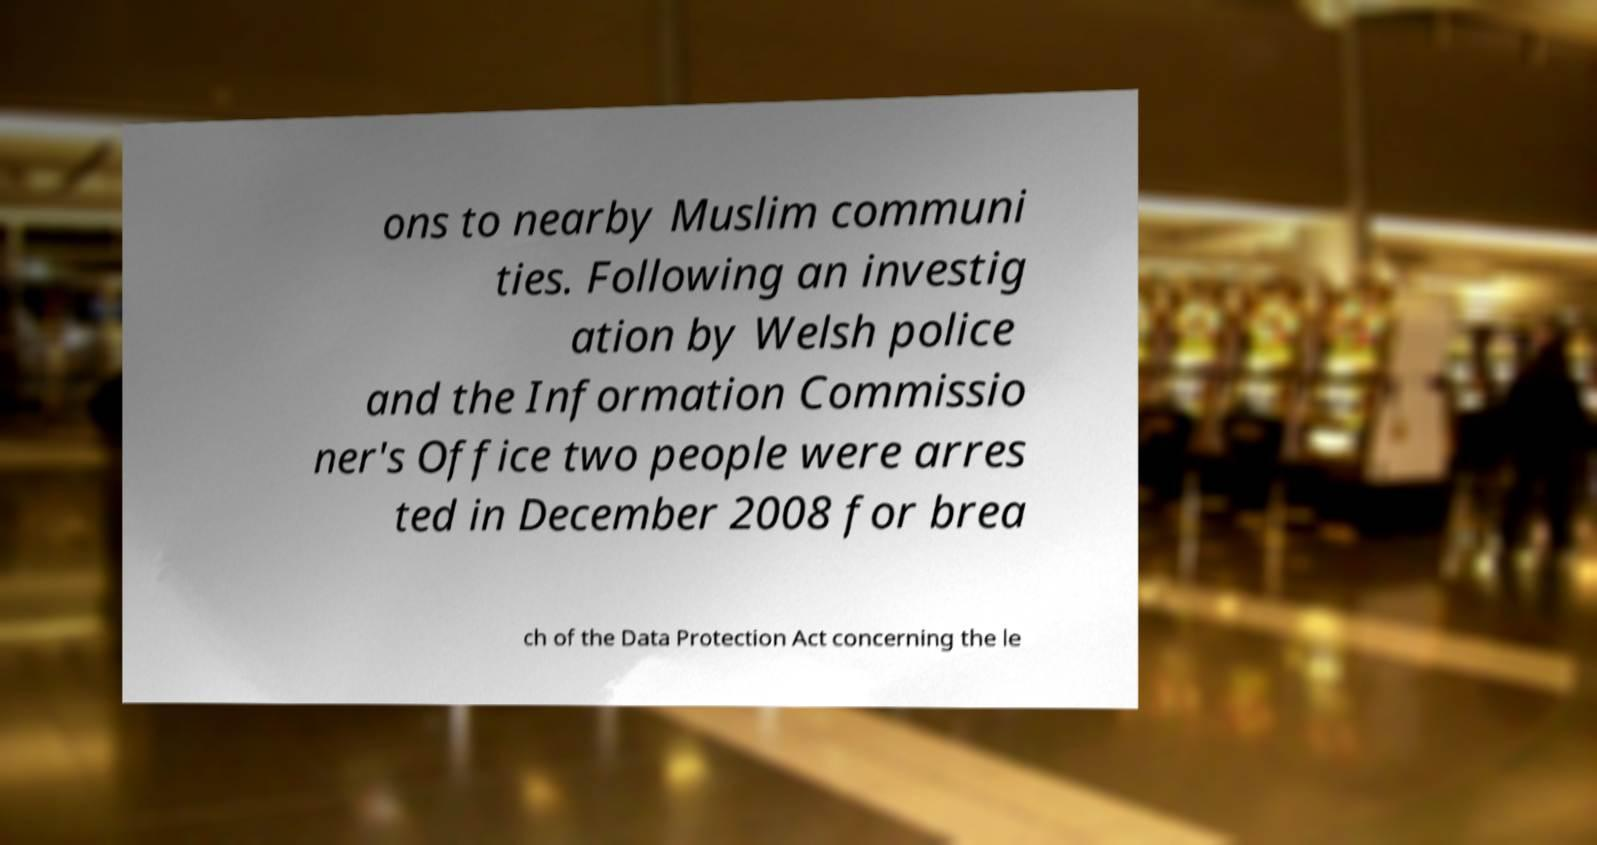What messages or text are displayed in this image? I need them in a readable, typed format. ons to nearby Muslim communi ties. Following an investig ation by Welsh police and the Information Commissio ner's Office two people were arres ted in December 2008 for brea ch of the Data Protection Act concerning the le 